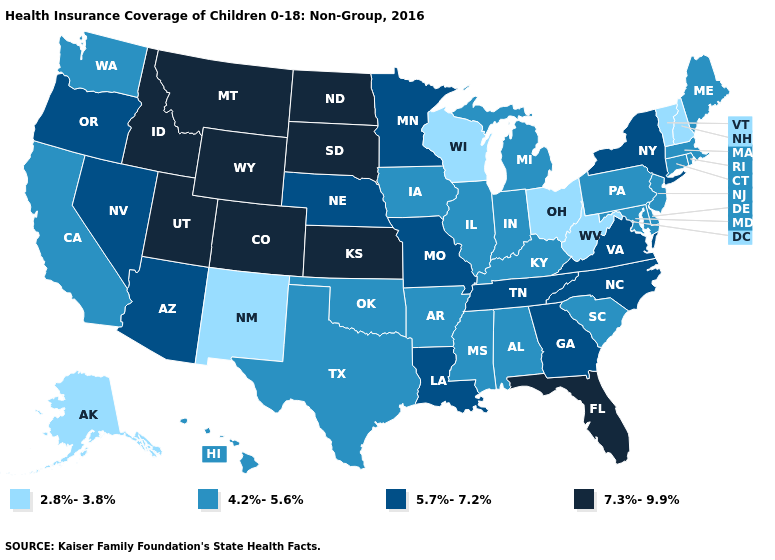Name the states that have a value in the range 2.8%-3.8%?
Keep it brief. Alaska, New Hampshire, New Mexico, Ohio, Vermont, West Virginia, Wisconsin. Does the map have missing data?
Short answer required. No. What is the lowest value in the West?
Write a very short answer. 2.8%-3.8%. Name the states that have a value in the range 4.2%-5.6%?
Be succinct. Alabama, Arkansas, California, Connecticut, Delaware, Hawaii, Illinois, Indiana, Iowa, Kentucky, Maine, Maryland, Massachusetts, Michigan, Mississippi, New Jersey, Oklahoma, Pennsylvania, Rhode Island, South Carolina, Texas, Washington. Does the map have missing data?
Concise answer only. No. Among the states that border New Mexico , which have the highest value?
Concise answer only. Colorado, Utah. What is the lowest value in the USA?
Write a very short answer. 2.8%-3.8%. Among the states that border Kansas , does Nebraska have the lowest value?
Quick response, please. No. Name the states that have a value in the range 5.7%-7.2%?
Be succinct. Arizona, Georgia, Louisiana, Minnesota, Missouri, Nebraska, Nevada, New York, North Carolina, Oregon, Tennessee, Virginia. What is the highest value in the USA?
Keep it brief. 7.3%-9.9%. What is the value of Washington?
Give a very brief answer. 4.2%-5.6%. Name the states that have a value in the range 7.3%-9.9%?
Quick response, please. Colorado, Florida, Idaho, Kansas, Montana, North Dakota, South Dakota, Utah, Wyoming. What is the highest value in states that border Tennessee?
Concise answer only. 5.7%-7.2%. What is the value of Louisiana?
Concise answer only. 5.7%-7.2%. 